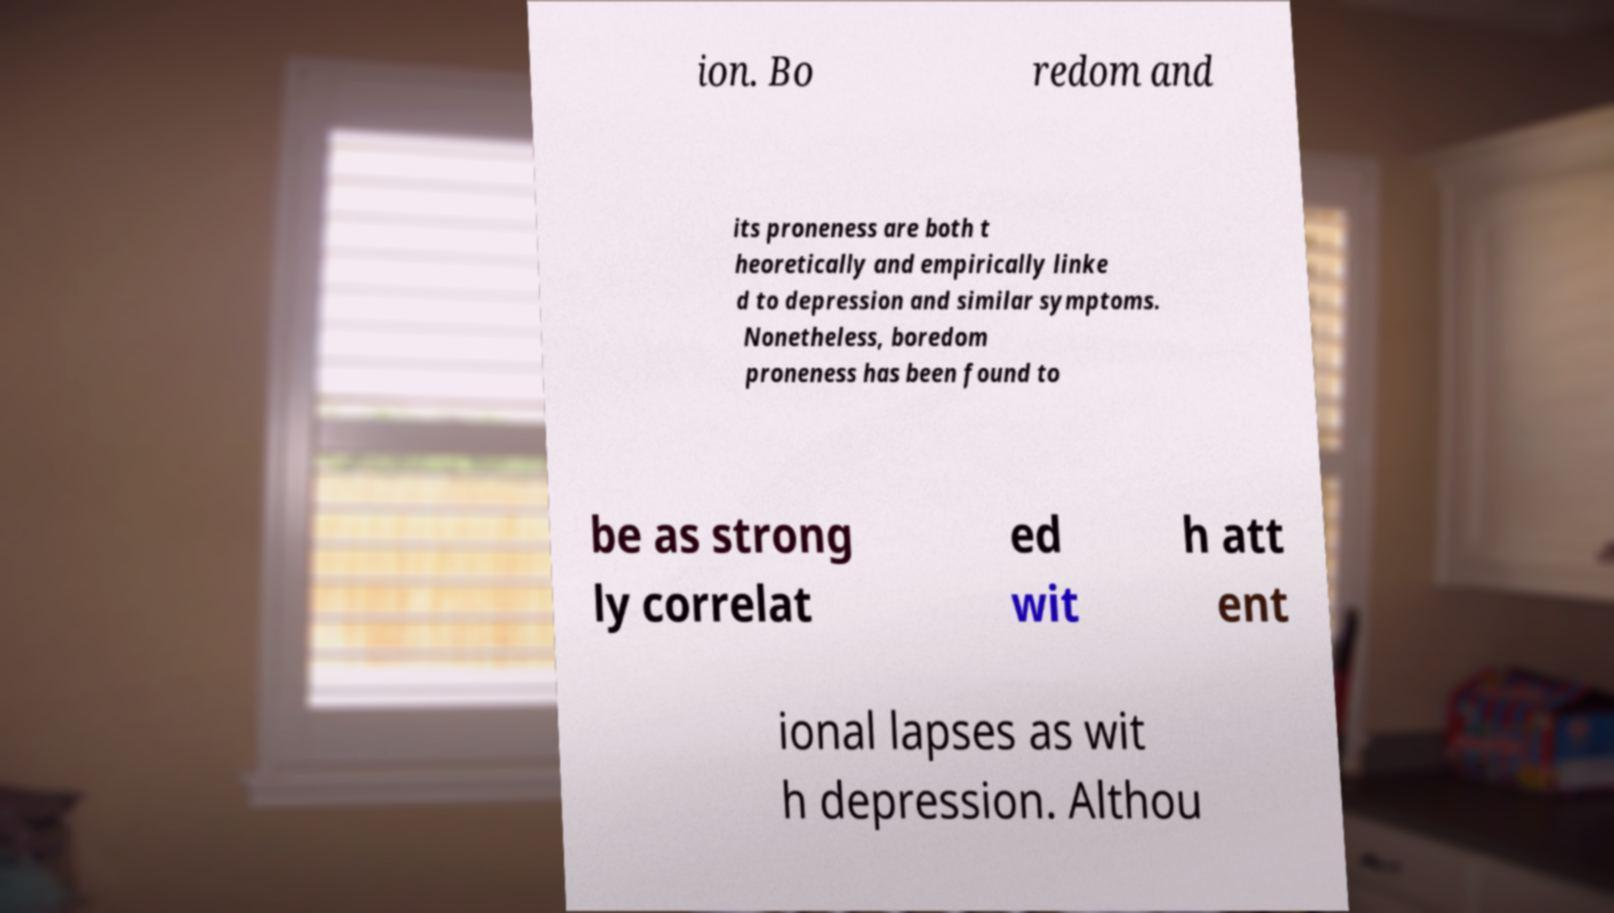Can you read and provide the text displayed in the image?This photo seems to have some interesting text. Can you extract and type it out for me? ion. Bo redom and its proneness are both t heoretically and empirically linke d to depression and similar symptoms. Nonetheless, boredom proneness has been found to be as strong ly correlat ed wit h att ent ional lapses as wit h depression. Althou 